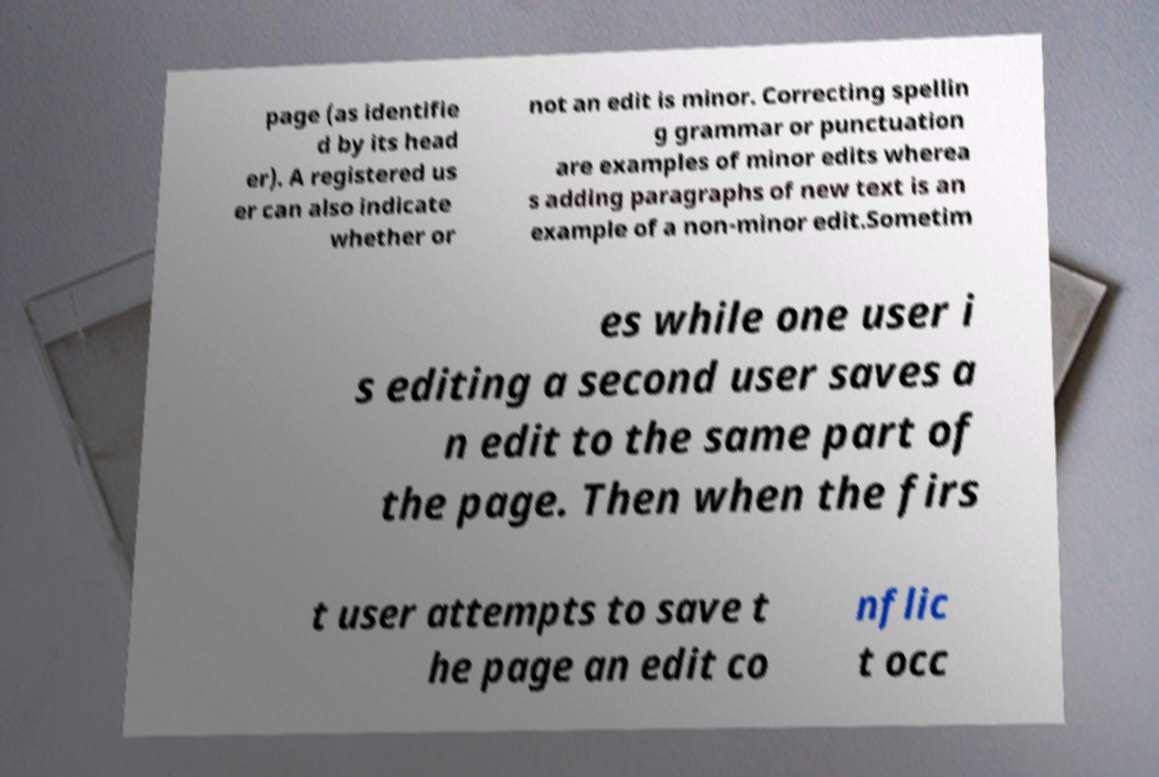Could you assist in decoding the text presented in this image and type it out clearly? page (as identifie d by its head er). A registered us er can also indicate whether or not an edit is minor. Correcting spellin g grammar or punctuation are examples of minor edits wherea s adding paragraphs of new text is an example of a non-minor edit.Sometim es while one user i s editing a second user saves a n edit to the same part of the page. Then when the firs t user attempts to save t he page an edit co nflic t occ 